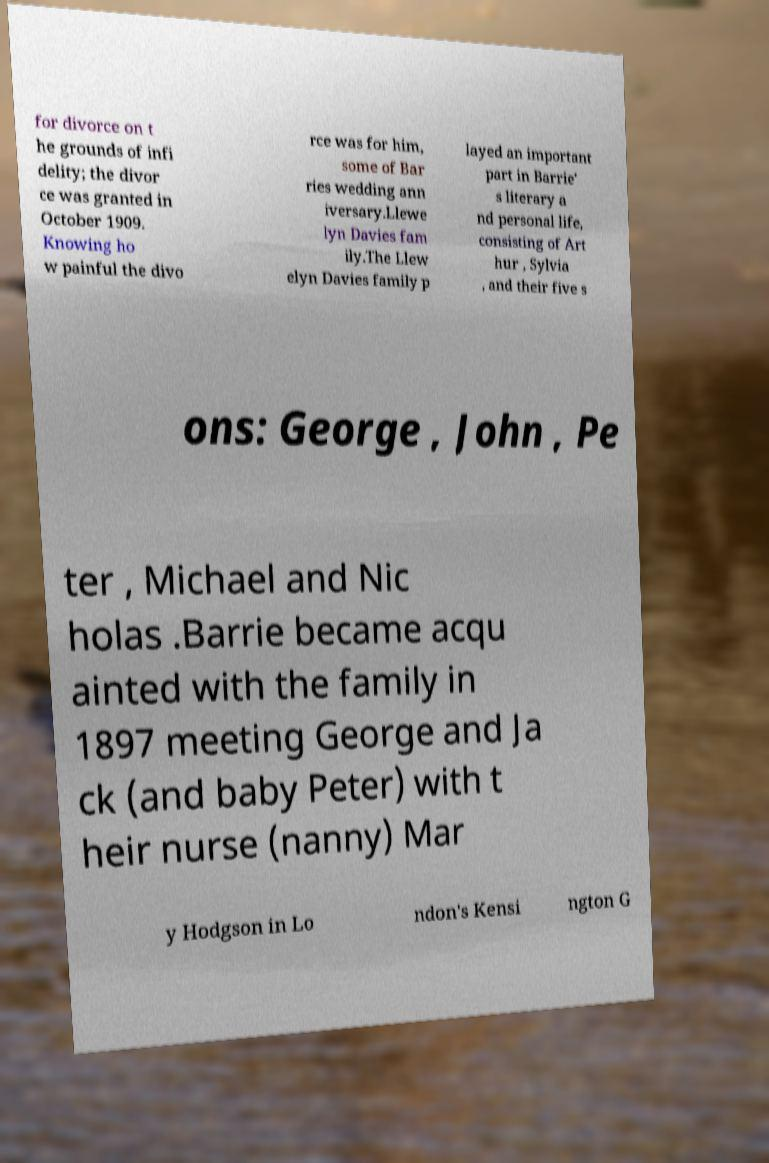Please identify and transcribe the text found in this image. for divorce on t he grounds of infi delity; the divor ce was granted in October 1909. Knowing ho w painful the divo rce was for him, some of Bar ries wedding ann iversary.Llewe lyn Davies fam ily.The Llew elyn Davies family p layed an important part in Barrie' s literary a nd personal life, consisting of Art hur , Sylvia , and their five s ons: George , John , Pe ter , Michael and Nic holas .Barrie became acqu ainted with the family in 1897 meeting George and Ja ck (and baby Peter) with t heir nurse (nanny) Mar y Hodgson in Lo ndon's Kensi ngton G 